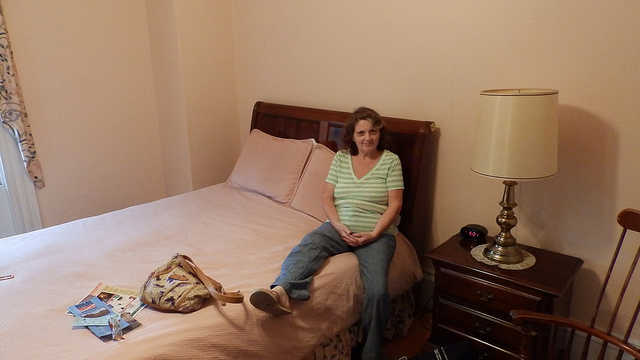What style is the furniture in the room reflective of? The furniture, including a traditional wooden bed frame and a matching nightstand with a classic lamp, reflect a classic, possibly mid-century style. 